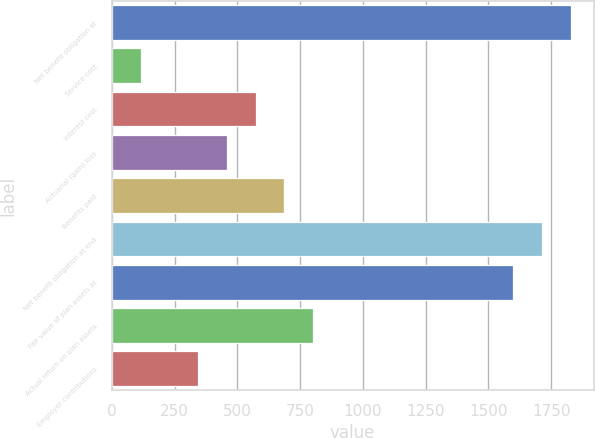Convert chart. <chart><loc_0><loc_0><loc_500><loc_500><bar_chart><fcel>Net benefit obligation at<fcel>Service cost<fcel>Interest cost<fcel>Actuarial (gain) loss<fcel>Benefits paid<fcel>Net benefit obligation at end<fcel>Fair value of plan assets at<fcel>Actual return on plan assets<fcel>Employer contributions<nl><fcel>1827<fcel>117<fcel>573<fcel>459<fcel>687<fcel>1713<fcel>1599<fcel>801<fcel>345<nl></chart> 